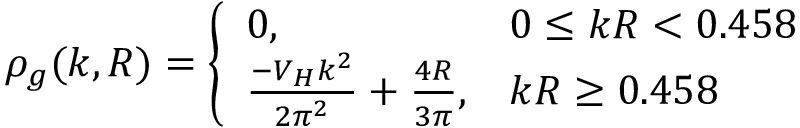Convert formula to latex. <formula><loc_0><loc_0><loc_500><loc_500>\rho _ { g } ( k , R ) = \left \{ \begin{array} { l l } { 0 , } & { 0 \leq k R < 0 . 4 5 8 } \\ { { \frac { - V _ { H } k ^ { 2 } } { 2 \pi ^ { 2 } } + \frac { 4 R } { 3 \pi } , } } & { k R \geq 0 . 4 5 8 } \end{array}</formula> 